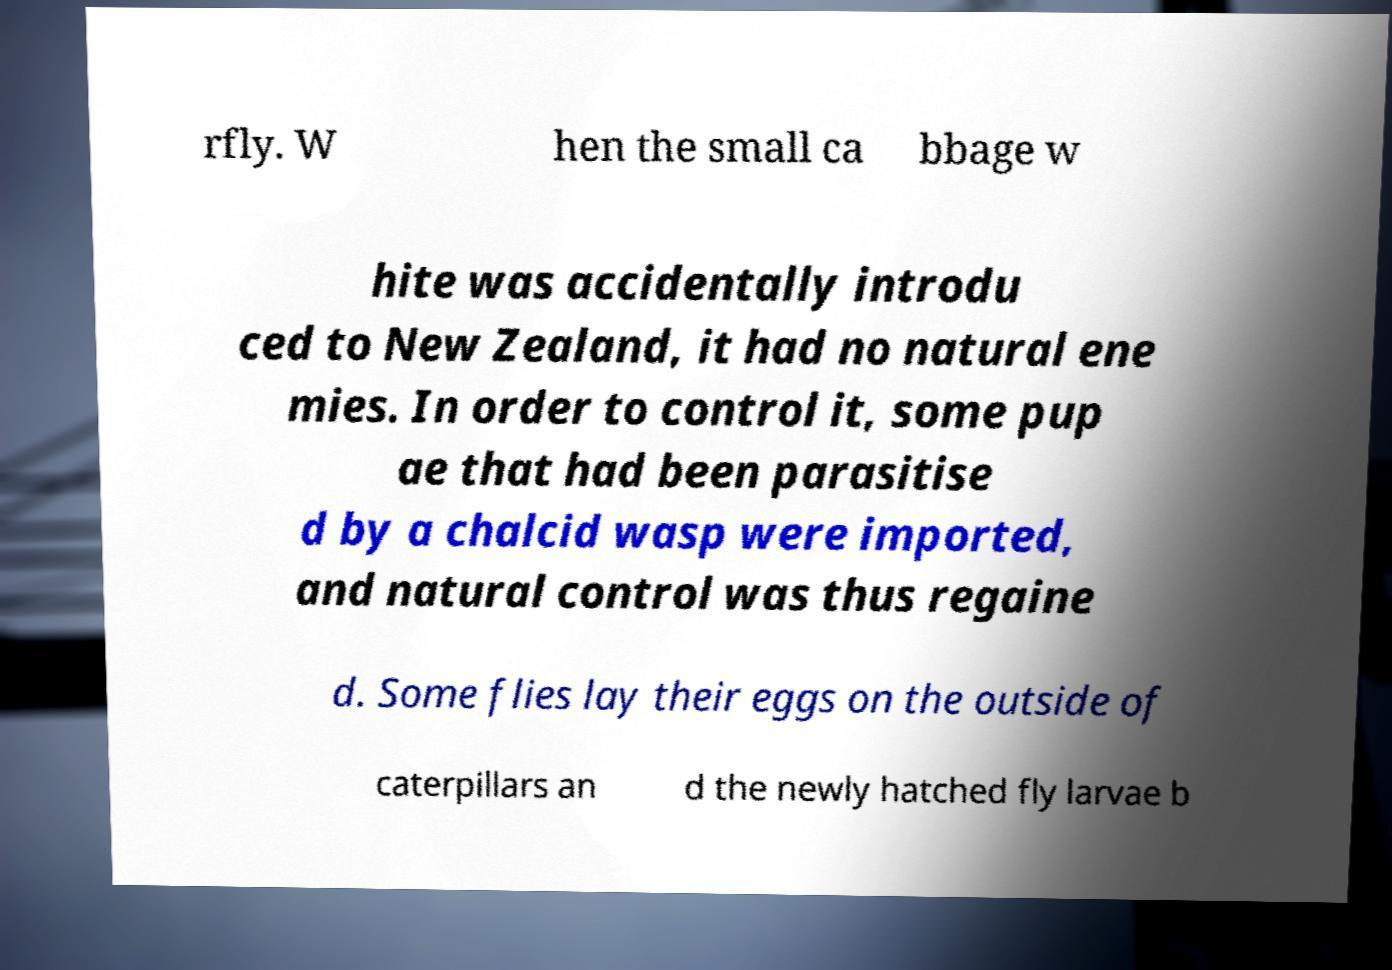For documentation purposes, I need the text within this image transcribed. Could you provide that? rfly. W hen the small ca bbage w hite was accidentally introdu ced to New Zealand, it had no natural ene mies. In order to control it, some pup ae that had been parasitise d by a chalcid wasp were imported, and natural control was thus regaine d. Some flies lay their eggs on the outside of caterpillars an d the newly hatched fly larvae b 